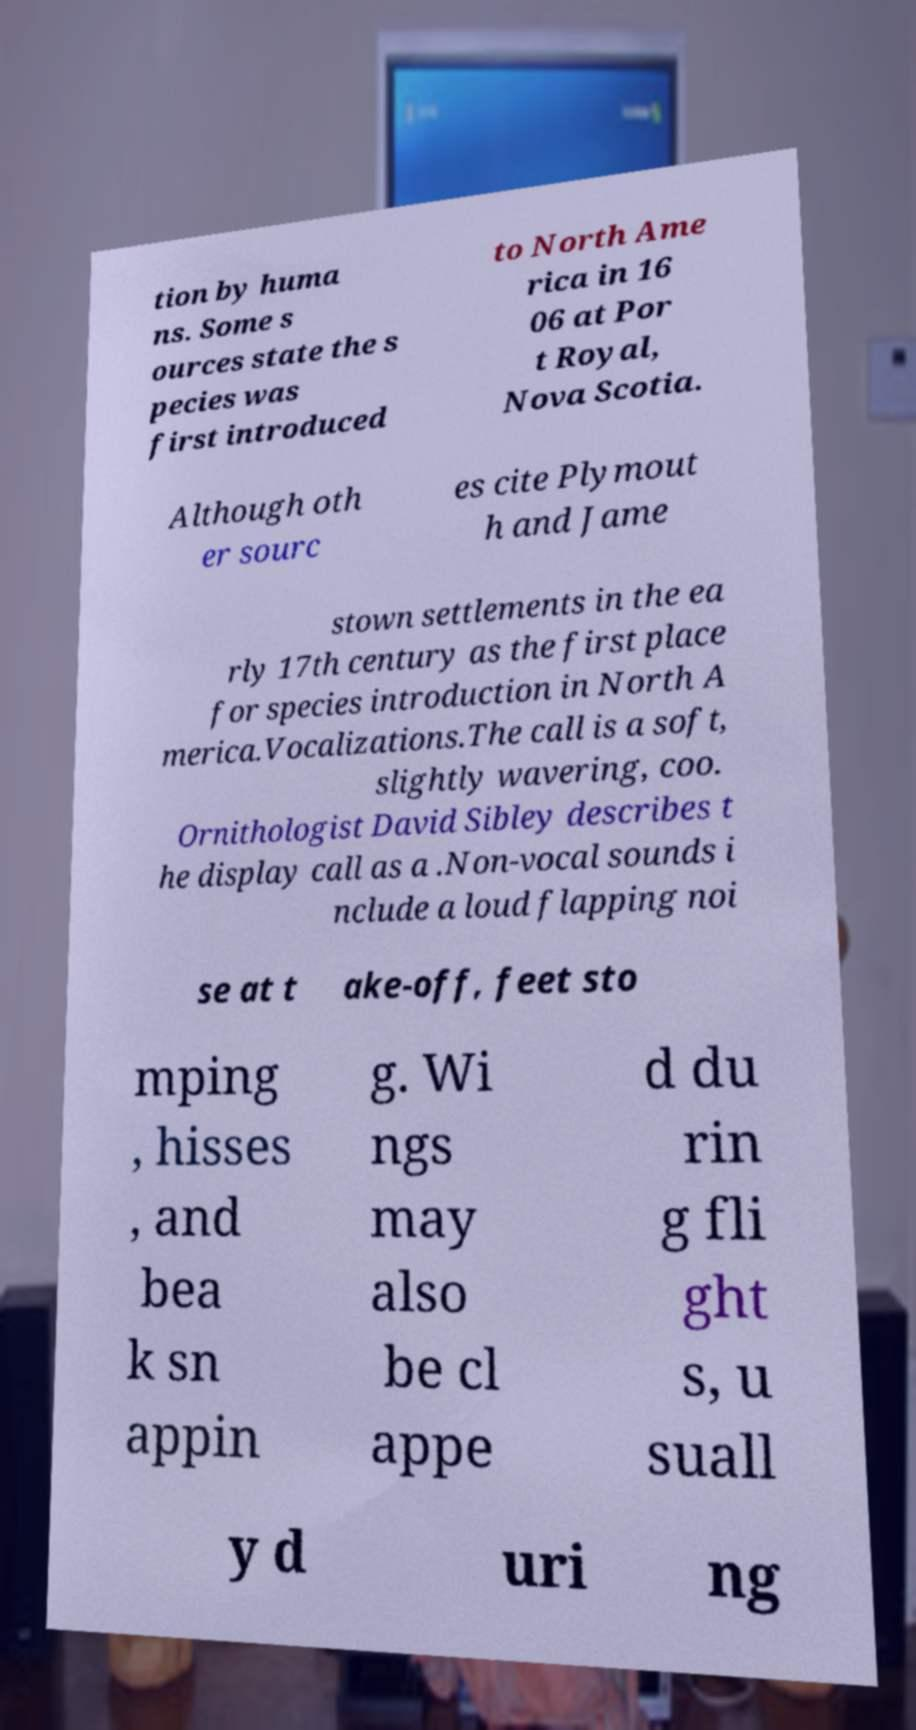What messages or text are displayed in this image? I need them in a readable, typed format. tion by huma ns. Some s ources state the s pecies was first introduced to North Ame rica in 16 06 at Por t Royal, Nova Scotia. Although oth er sourc es cite Plymout h and Jame stown settlements in the ea rly 17th century as the first place for species introduction in North A merica.Vocalizations.The call is a soft, slightly wavering, coo. Ornithologist David Sibley describes t he display call as a .Non-vocal sounds i nclude a loud flapping noi se at t ake-off, feet sto mping , hisses , and bea k sn appin g. Wi ngs may also be cl appe d du rin g fli ght s, u suall y d uri ng 